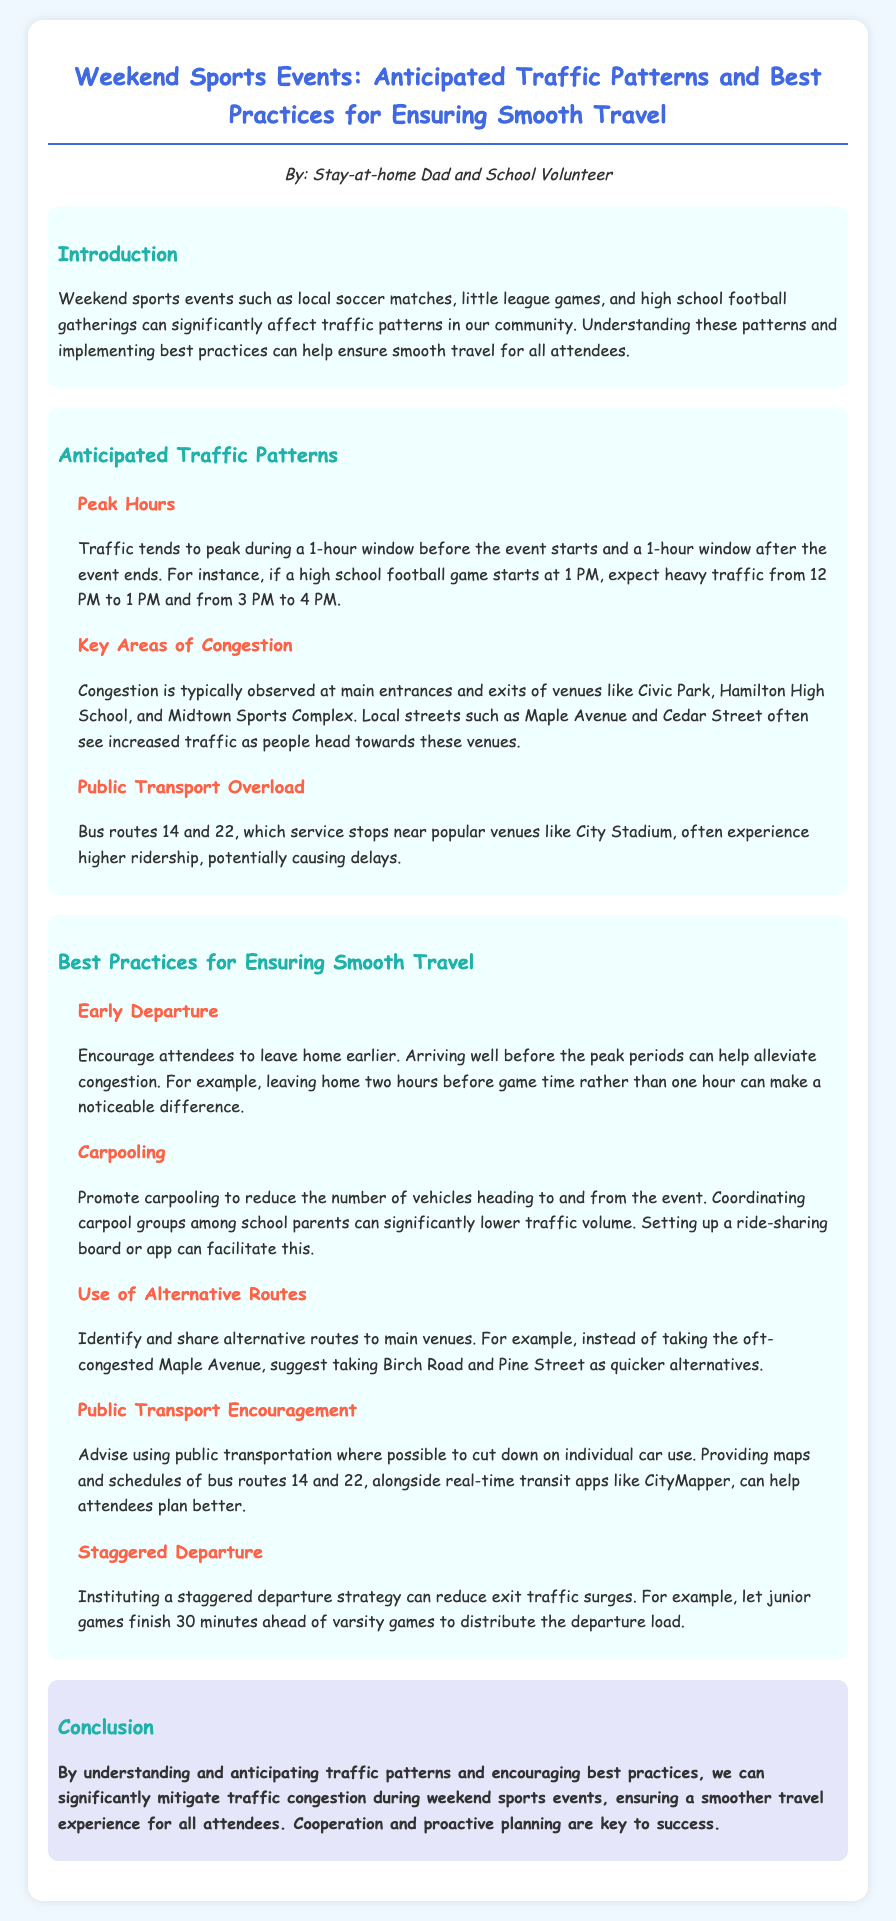What are the peak hours for traffic during events? Peak traffic occurs during a 1-hour window before and after the event. For example, if a game starts at 1 PM, expect heavy traffic from 12 PM to 1 PM and from 3 PM to 4 PM.
Answer: 12 PM to 1 PM and 3 PM to 4 PM What is a suggested time for early departure? To alleviate congestion, it is recommended to leave home earlier, ideally two hours before game time.
Answer: Two hours Which streets are mentioned as often congested? Local streets such as Maple Avenue and Cedar Street often see increased traffic.
Answer: Maple Avenue and Cedar Street What method is recommended to reduce vehicles? Carpooling is promoted to reduce the number of vehicles heading to and from the event.
Answer: Carpooling What is a suggested alternative route? Instead of taking congested Maple Avenue, Birch Road and Pine Street are suggested as quicker alternatives.
Answer: Birch Road and Pine Street Which bus routes experience higher ridership? Bus routes 14 and 22, servicing stops near popular venues, often experience higher ridership.
Answer: Bus routes 14 and 22 What practice can help in reducing exit traffic surges? Instituting a staggered departure strategy can help reduce exit traffic surges.
Answer: Staggered departure What type of events impact local traffic? Weekend sports events such as local soccer matches and high school football gatherings significantly affect traffic.
Answer: Weekend sports events What is the overall goal of the report? The goal is to mitigate traffic congestion during weekend sports events for a smoother travel experience.
Answer: Mitigate traffic congestion 